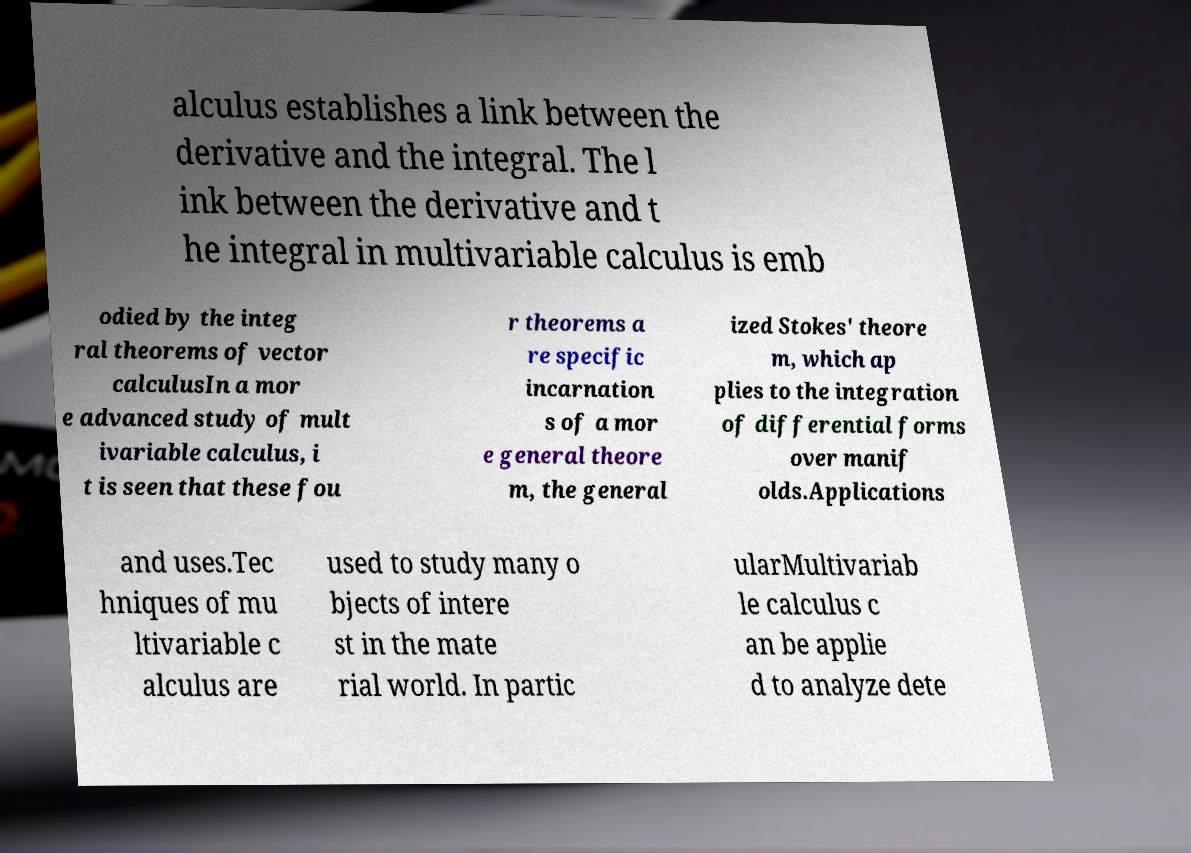There's text embedded in this image that I need extracted. Can you transcribe it verbatim? alculus establishes a link between the derivative and the integral. The l ink between the derivative and t he integral in multivariable calculus is emb odied by the integ ral theorems of vector calculusIn a mor e advanced study of mult ivariable calculus, i t is seen that these fou r theorems a re specific incarnation s of a mor e general theore m, the general ized Stokes' theore m, which ap plies to the integration of differential forms over manif olds.Applications and uses.Tec hniques of mu ltivariable c alculus are used to study many o bjects of intere st in the mate rial world. In partic ularMultivariab le calculus c an be applie d to analyze dete 